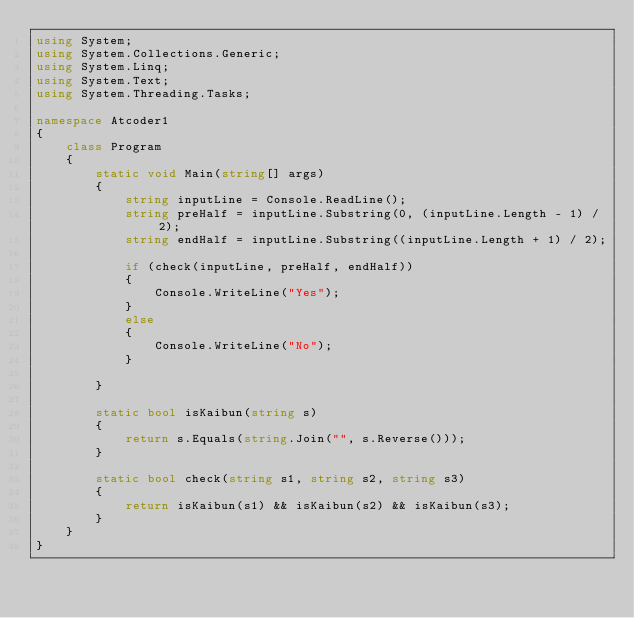<code> <loc_0><loc_0><loc_500><loc_500><_C#_>using System;
using System.Collections.Generic;
using System.Linq;
using System.Text;
using System.Threading.Tasks;

namespace Atcoder1
{
    class Program
    {
        static void Main(string[] args)
        {
            string inputLine = Console.ReadLine();
            string preHalf = inputLine.Substring(0, (inputLine.Length - 1) / 2);
            string endHalf = inputLine.Substring((inputLine.Length + 1) / 2);

            if (check(inputLine, preHalf, endHalf))
            {
                Console.WriteLine("Yes");
            }
            else
            {
                Console.WriteLine("No");
            }

        }

        static bool isKaibun(string s)
        {
            return s.Equals(string.Join("", s.Reverse()));
        }

        static bool check(string s1, string s2, string s3)
        {
            return isKaibun(s1) && isKaibun(s2) && isKaibun(s3);
        }
    }
}</code> 